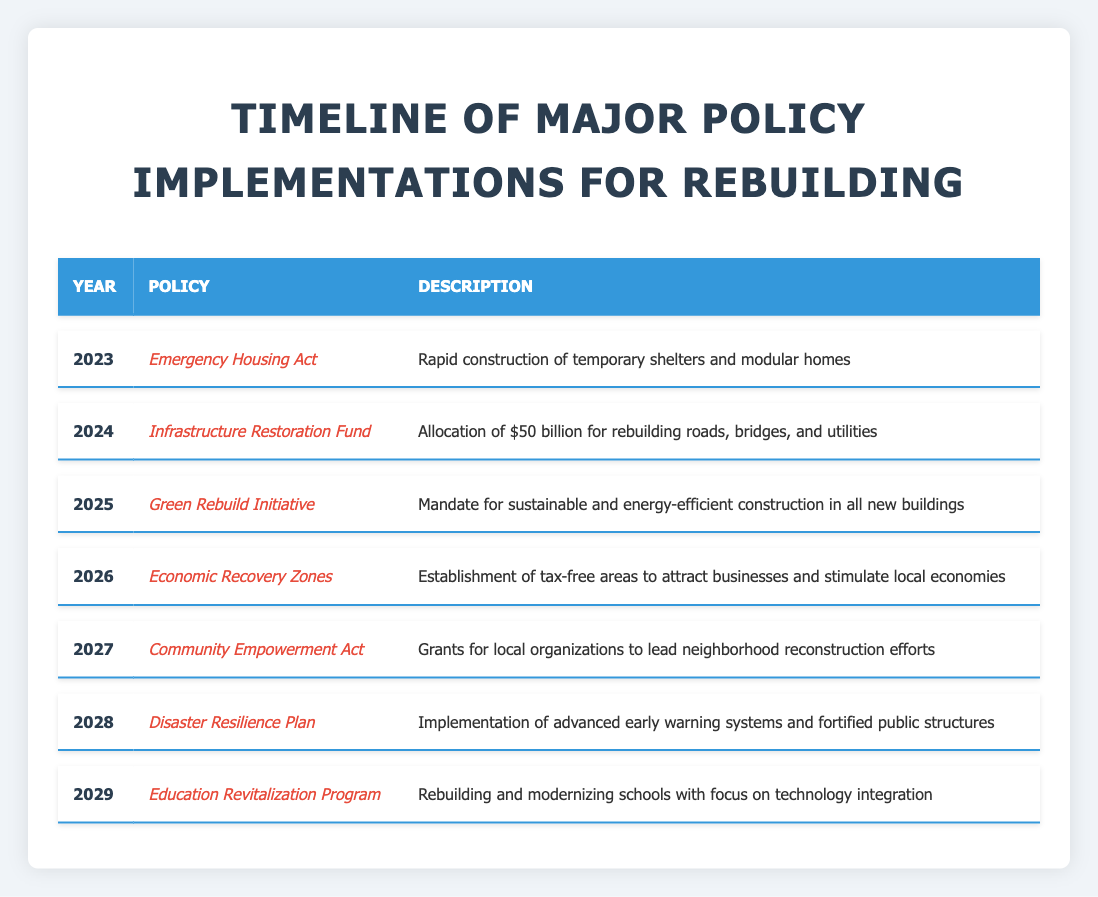What policy was implemented in 2023? According to the table, the policy implemented in 2023 is the "Emergency Housing Act." This is mentioned directly in the row corresponding to the year 2023.
Answer: Emergency Housing Act How much funding was allocated for the Infrastructure Restoration Fund? The table states that the Infrastructure Restoration Fund in 2024 allocated "$50 billion" for rebuilding. This specific amount is found in the row for 2024.
Answer: $50 billion Which policy focuses on sustainability in construction? The "Green Rebuild Initiative," implemented in 2025, is focused on sustainable and energy-efficient construction as per the table's description for that year.
Answer: Green Rebuild Initiative Is there a policy aimed at the education sector? Yes, the "Education Revitalization Program" set for 2029 focuses on rebuilding and modernizing schools, as indicated in the description for that year.
Answer: Yes Which policy is designed to stimulate local economies through tax incentives? The "Economic Recovery Zones," established in 2026, aims to attract businesses and stimulate local economies through the creation of tax-free areas, as noted in its description.
Answer: Economic Recovery Zones How many policies are set for implementation between 2023 and 2028? The table lists six policies from 2023 (Emergency Housing Act) to 2028 (Disaster Resilience Plan). By counting these years, we find there are six policies in total.
Answer: Six What is the purpose of the Community Empowerment Act? The Community Empowerment Act, effective in 2027, offers grants for local organizations to lead neighborhood reconstruction efforts, according to its description in the table.
Answer: Grants for local organizations In which year does the policy for advanced early warning systems come? The policy for advanced early warning systems is part of the "Disaster Resilience Plan," which is set for implementation in 2028, as shown in the corresponding row.
Answer: 2028 What two policies focus on rebuilding infrastructure? The two policies that focus on rebuilding infrastructure are the "Infrastructure Restoration Fund" in 2024 and the "Education Revitalization Program" in 2029. The former focuses on roads and utilities, while the latter focuses on schools.
Answer: Infrastructure Restoration Fund and Education Revitalization Program 